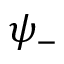Convert formula to latex. <formula><loc_0><loc_0><loc_500><loc_500>\psi _ { - }</formula> 